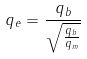<formula> <loc_0><loc_0><loc_500><loc_500>q _ { e } = \frac { q _ { b } } { \sqrt { \frac { q _ { b } } { q _ { m } } } }</formula> 